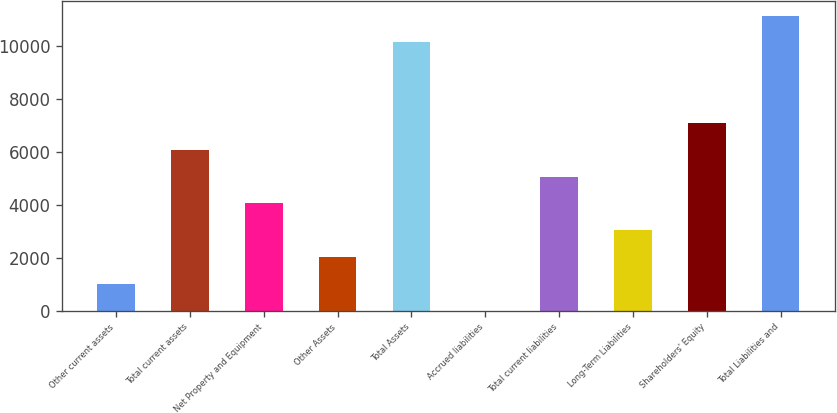Convert chart. <chart><loc_0><loc_0><loc_500><loc_500><bar_chart><fcel>Other current assets<fcel>Total current assets<fcel>Net Property and Equipment<fcel>Other Assets<fcel>Total Assets<fcel>Accrued liabilities<fcel>Total current liabilities<fcel>Long-Term Liabilities<fcel>Shareholders' Equity<fcel>Total Liabilities and<nl><fcel>1018<fcel>6073<fcel>4051<fcel>2029<fcel>10117<fcel>7<fcel>5062<fcel>3040<fcel>7084<fcel>11128<nl></chart> 